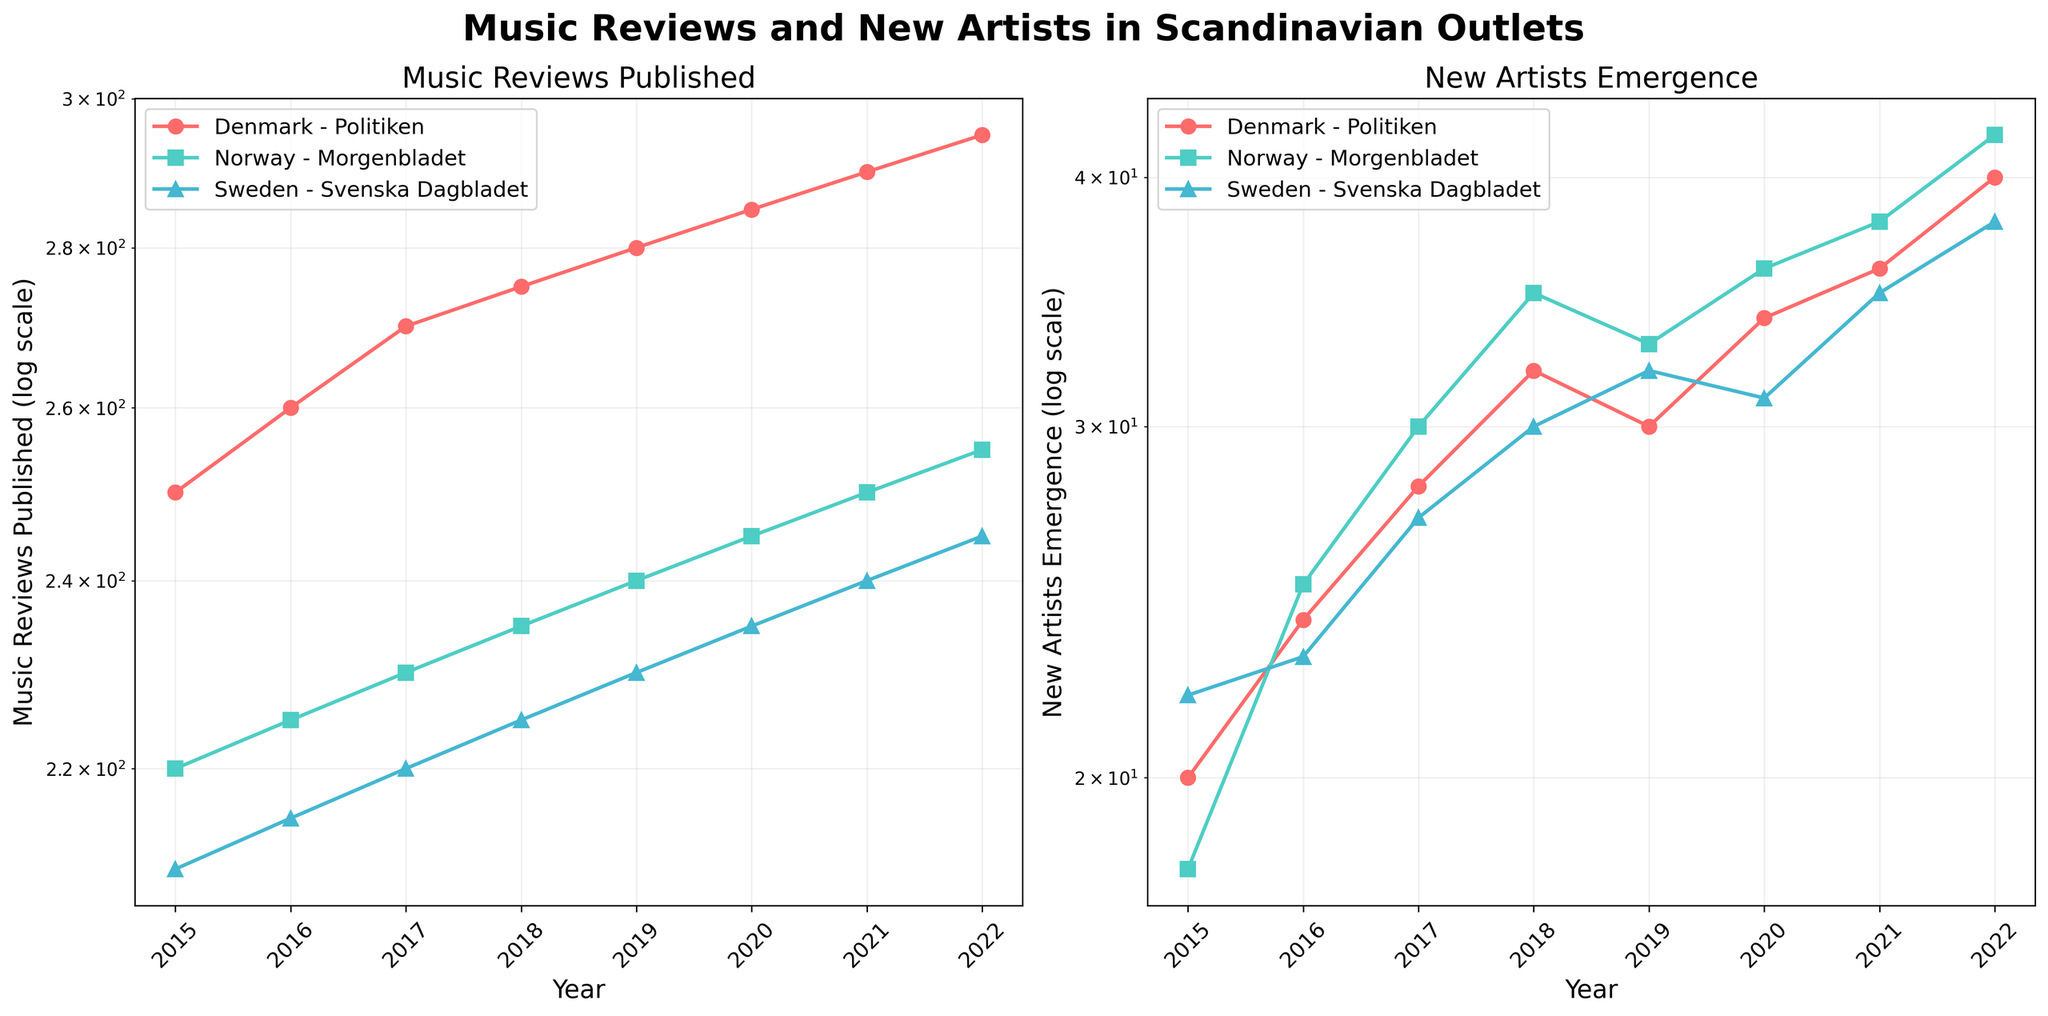What is the title of the figure? The title of the figure is displayed at the top and reads "Music Reviews and New Artists in Scandinavian Outlets".
Answer: Music Reviews and New Artists in Scandinavian Outlets Which country had the highest number of music reviews published in 2022? By looking at the subplot on the left for "Music Reviews Published", in 2022, the marker with the highest position on the y-axis belongs to Politiken from Denmark.
Answer: Denmark (Politiken) In which year did Norway's major outlet publish 240 music reviews? Refer to the subplot on the left and look for the point labeled "Norway - Morgenbladet" on the y-axis value of approximately 240. This occurred in 2019.
Answer: 2019 What is the overall trend for new artists emerging in Sweden from 2015 to 2022? By examining the subplot on the right for "New Artists Emergence", we notice that the points labeled "Sweden - Svenska Dagbladet" generally increase from 2015 to 2022, indicating an upward trend.
Answer: Upward trend Comparing Denmark and Sweden, which country had a higher emergence of new artists in 2018? On the right-hand subplot, check the 2018 markers. Denmark (Politiken) has a higher y-value than Sweden (Svenska Dagbladet).
Answer: Denmark What is the average number of new artists emerging in Norway between 2017 and 2020? To find this, obtain the values for Norway in 2017 (30), 2018 (35), 2019 (33), and 2020 (36). The average is calculated as (30 + 35 + 33 + 36) / 4 = 33.5.
Answer: 33.5 How many new artists emerged in Denmark in 2021, and how does this compare to 2019? Look at the data points on the right subplot for Denmark (Politiken). In 2019, the number is 30; in 2021, it is 36. Subtract 30 from 36 to find the increase.
Answer: Denmark saw an increase of 6 new artists in 2021 compared to 2019 Which country showed the smallest difference in the number of music reviews published between 2015 and 2022? Examine the vertical distances between the 2015 and 2022 markers on the left subplot for each country. Sweden (Svenska Dagbladet) shows the smallest difference.
Answer: Sweden (Svenska Dagbladet) What is the relationship between the quantity of music reviews published and the emergence of new artists for Denmark over time? Comparing both subplots, notably for Denmark (Politiken), as the number of music reviews published increases, the emergence of new artists also trends upwards. This suggests a positive correlation.
Answer: Positive correlation 